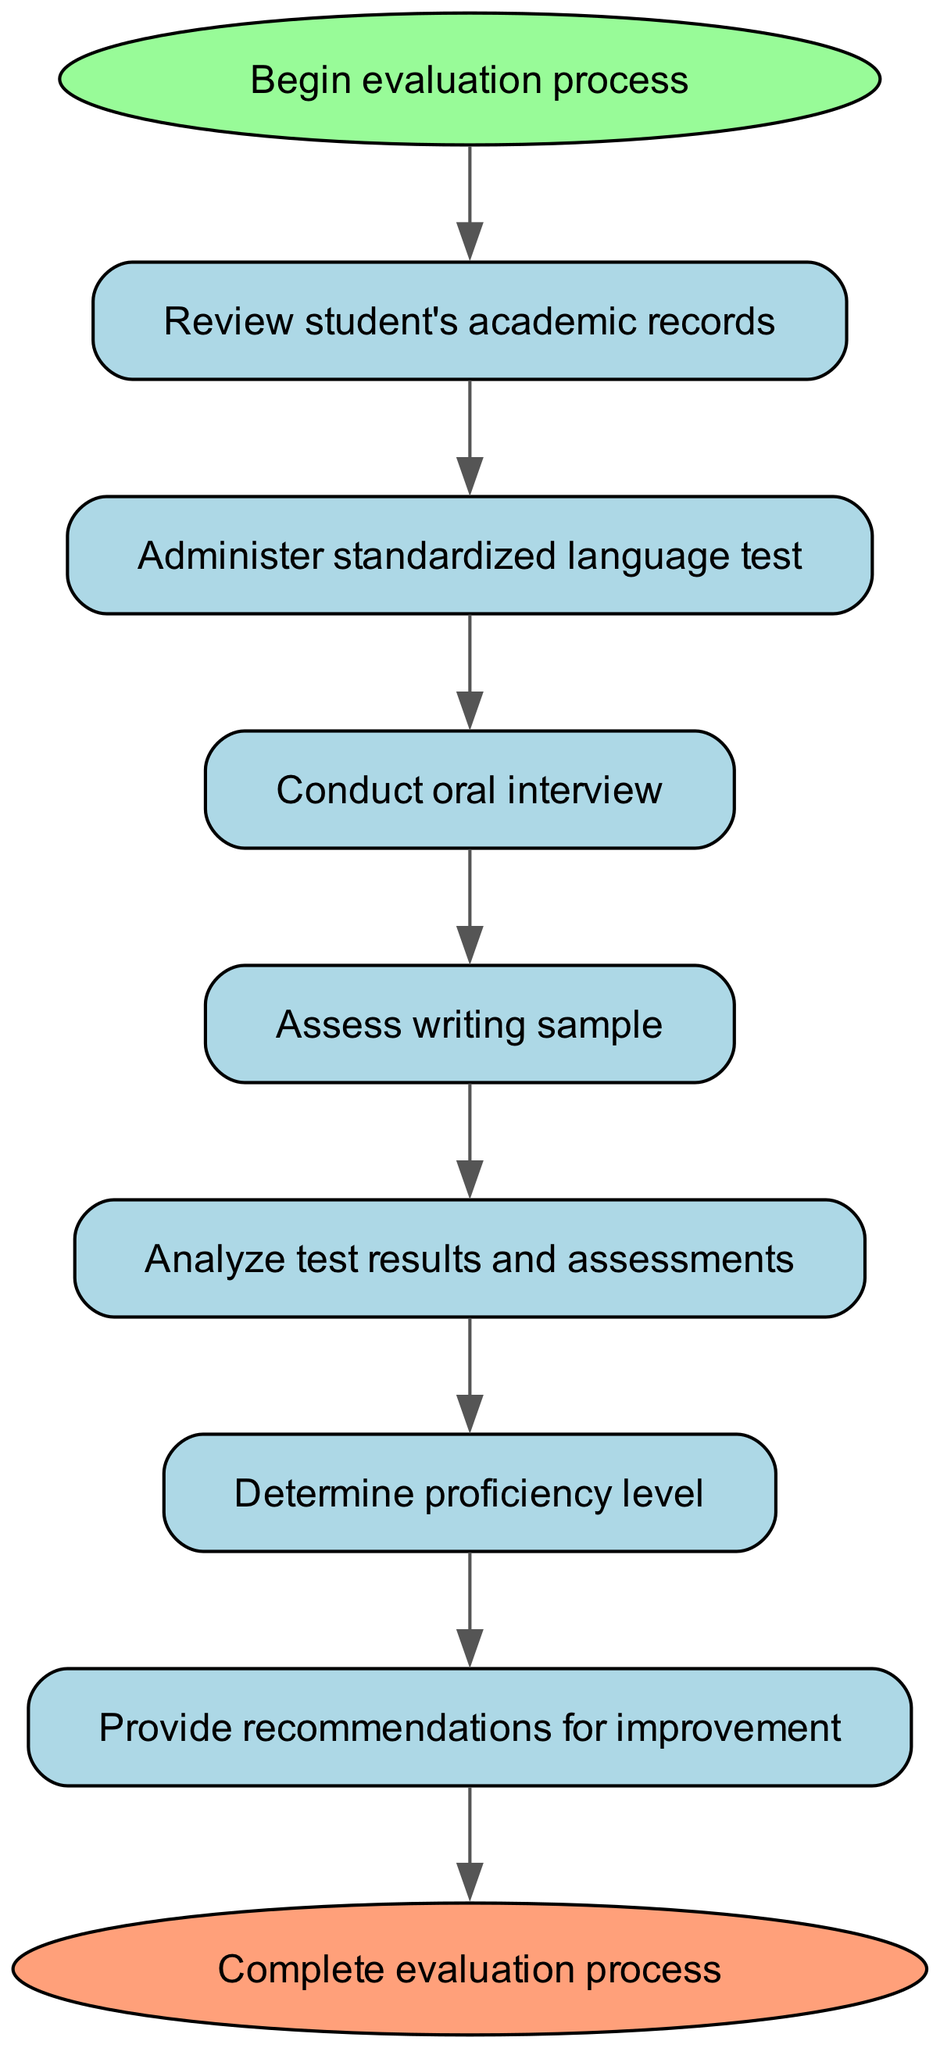What is the first step in the evaluation process? The first step, indicated in the diagram, is labeled "Review student's academic records." It appears as the first node connected to the start.
Answer: Review student's academic records How many total steps are there in the evaluation process? The diagram shows seven main process nodes (from the start to determining the proficiency level), plus the start and end nodes totaling nine.
Answer: Nine What action follows the administration of the standardized language test? According to the flow chart, after administering the standardized language test (the second node), the next step is to conduct an oral interview (the third node).
Answer: Conduct oral interview What is the last action performed before the process ends? The diagram indicates that the last action before reaching the end of the process is to provide recommendations for improvement, which is the seventh node.
Answer: Provide recommendations for improvement Which step assesses a student's writing ability? The assessment of the student's writing ability is depicted as the fourth step in the process, labeled "Assess writing sample." This connects from the previous step of conducting an oral interview.
Answer: Assess writing sample What determines the proficiency level? The sixth step in the diagram is where test results and assessments are analyzed to determine the proficiency level, which is the subsequent node.
Answer: Analyze test results and assessments How does the final output connect to the previous step? The final output connects directly from the last action of providing recommendations for improvement, indicating a straightforward flow from the analysis to the conclusion of the evaluation process.
Answer: Through a direct edge connection What type of test is administered in the second step? In the process described in the diagram, the second step specifically mentions the administration of a standardized language test, designated as such in the text of the node.
Answer: Standardized language test What is the role of the oral interview in this process? The oral interview serves as the third step, enabling evaluators to assess the student's verbal language skills following the standardized test, providing crucial qualitative data on proficiency.
Answer: Assess verbal skills 